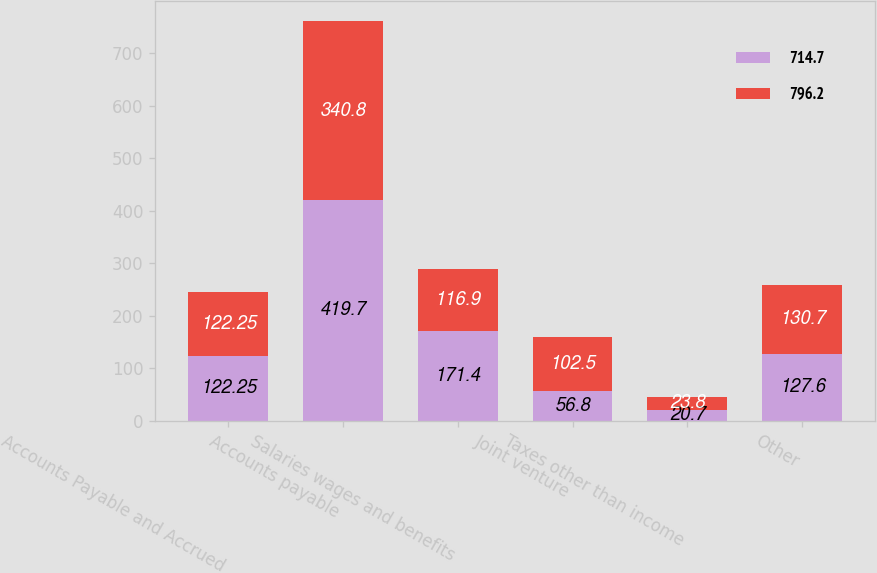Convert chart. <chart><loc_0><loc_0><loc_500><loc_500><stacked_bar_chart><ecel><fcel>Accounts Payable and Accrued<fcel>Accounts payable<fcel>Salaries wages and benefits<fcel>Joint venture<fcel>Taxes other than income<fcel>Other<nl><fcel>714.7<fcel>122.25<fcel>419.7<fcel>171.4<fcel>56.8<fcel>20.7<fcel>127.6<nl><fcel>796.2<fcel>122.25<fcel>340.8<fcel>116.9<fcel>102.5<fcel>23.8<fcel>130.7<nl></chart> 